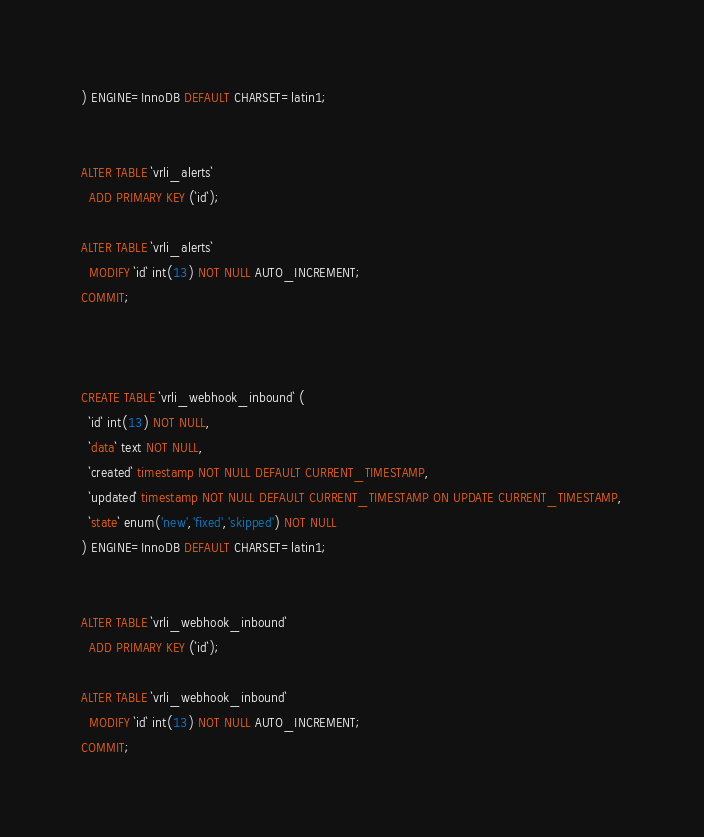<code> <loc_0><loc_0><loc_500><loc_500><_SQL_>) ENGINE=InnoDB DEFAULT CHARSET=latin1;


ALTER TABLE `vrli_alerts`
  ADD PRIMARY KEY (`id`);

ALTER TABLE `vrli_alerts`
  MODIFY `id` int(13) NOT NULL AUTO_INCREMENT;
COMMIT;



CREATE TABLE `vrli_webhook_inbound` (
  `id` int(13) NOT NULL,
  `data` text NOT NULL,
  `created` timestamp NOT NULL DEFAULT CURRENT_TIMESTAMP,
  `updated` timestamp NOT NULL DEFAULT CURRENT_TIMESTAMP ON UPDATE CURRENT_TIMESTAMP,
  `state` enum('new','fixed','skipped') NOT NULL
) ENGINE=InnoDB DEFAULT CHARSET=latin1;


ALTER TABLE `vrli_webhook_inbound`
  ADD PRIMARY KEY (`id`);
  
ALTER TABLE `vrli_webhook_inbound`
  MODIFY `id` int(13) NOT NULL AUTO_INCREMENT;
COMMIT;
</code> 